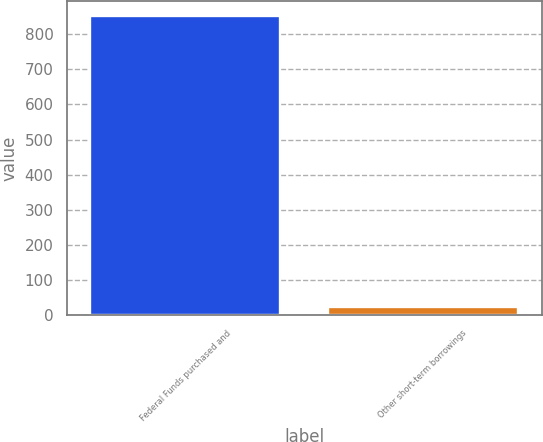Convert chart to OTSL. <chart><loc_0><loc_0><loc_500><loc_500><bar_chart><fcel>Federal Funds purchased and<fcel>Other short-term borrowings<nl><fcel>851<fcel>25<nl></chart> 